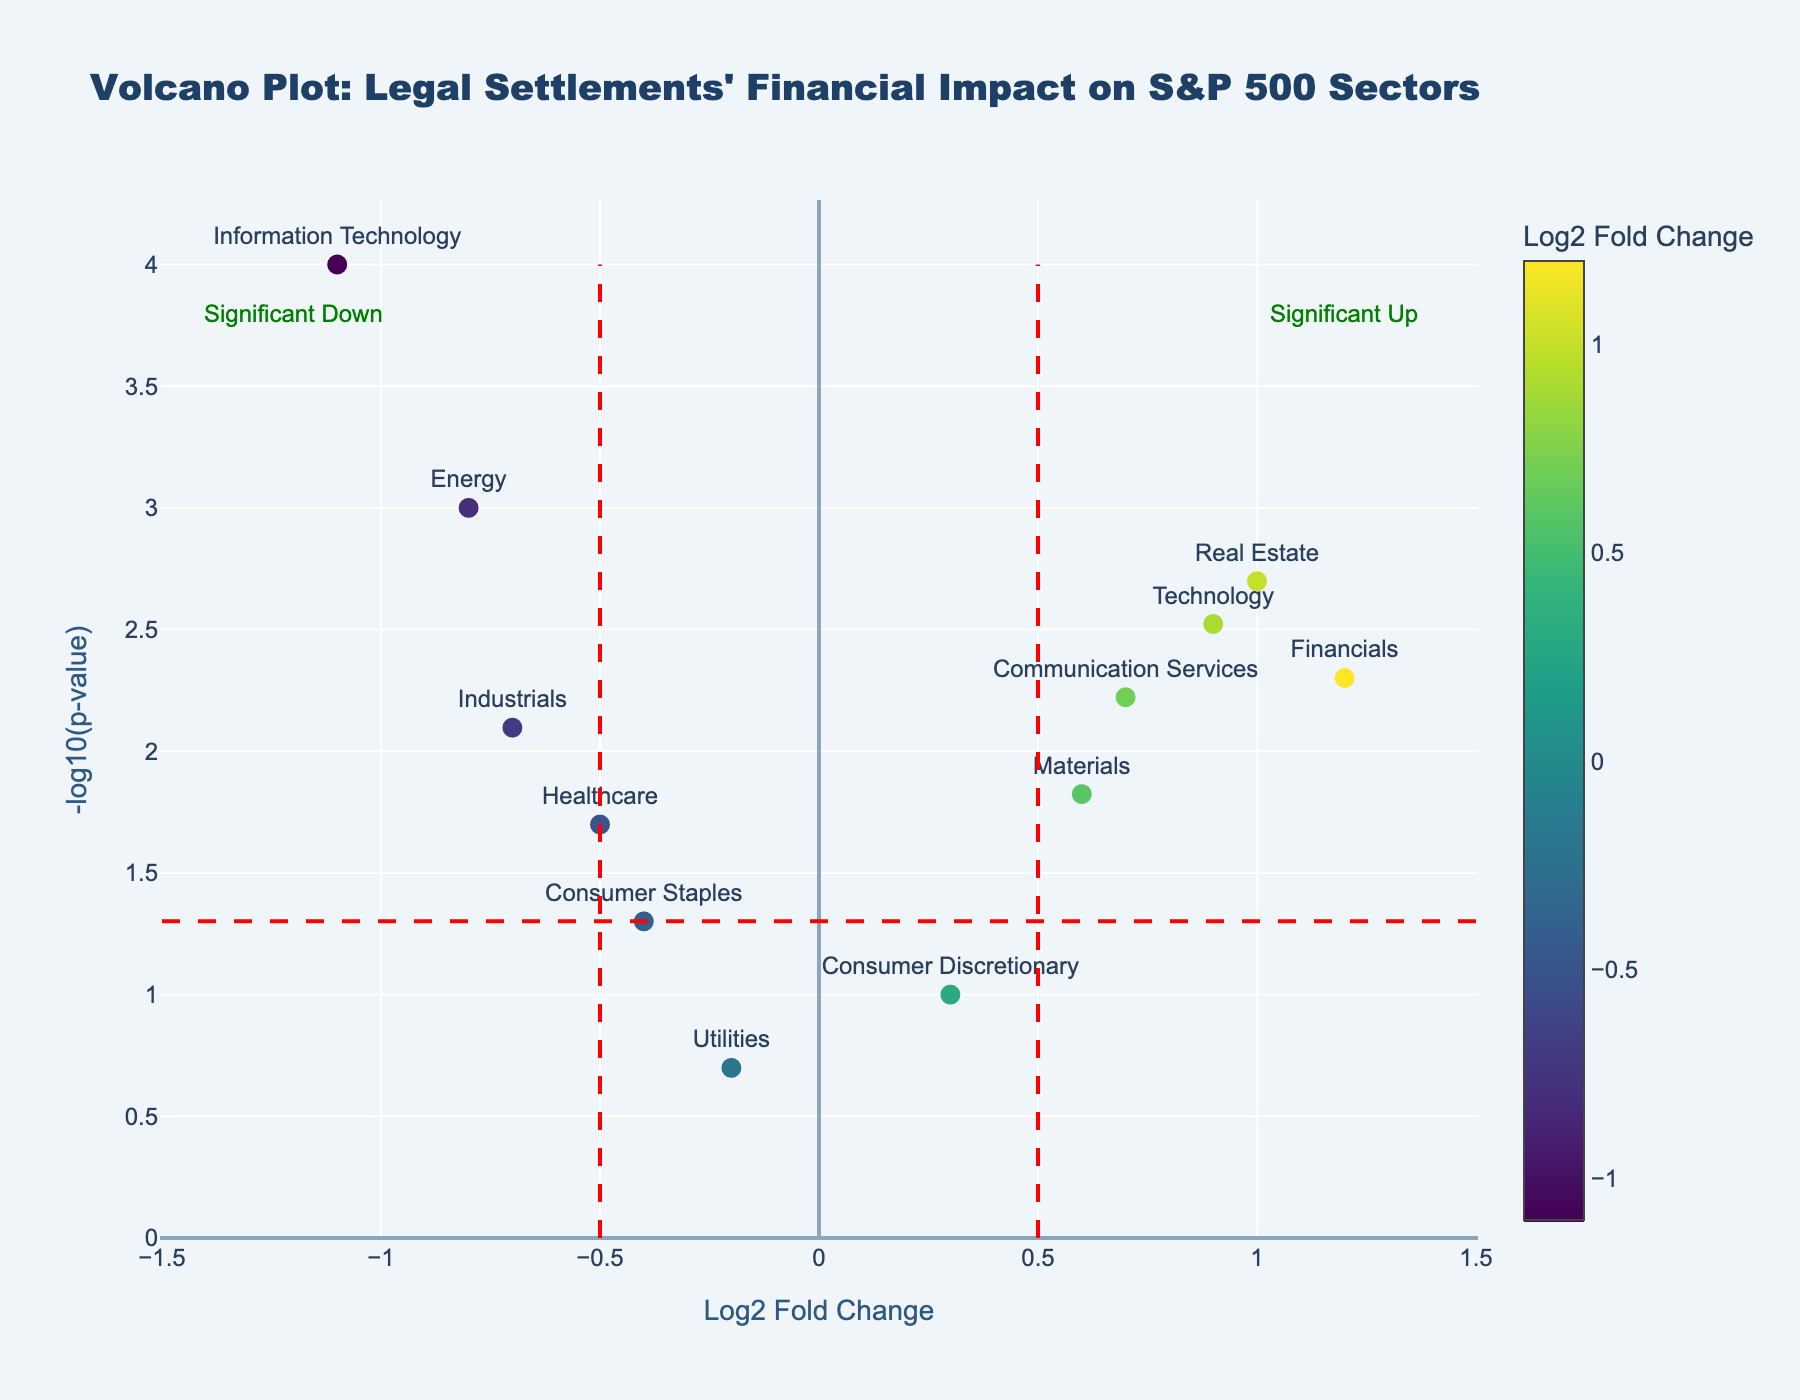What is the title of the figure? The title is at the top of the figure in large text and is easy to read. It helps contextualize what the plot is about. The title reads "Volcano Plot: Legal Settlements' Financial Impact on S&P 500 Sectors"
Answer: Volcano Plot: Legal Settlements' Financial Impact on S&P 500 Sectors How many data points are shown in the figure? Each marker represents a sector of the S&P 500, and by counting them, we find there are 12 data points.
Answer: 12 Which sector has the highest p-value? The p-value is shown on the y-axis, with lower values indicating higher points on the plot. The sector with the marker closest to the bottom of the plot is 'Utilities' with a p-value of 0.2.
Answer: Utilities Which sectors show a significant financial impact according to the fold-change threshold? Markers beyond the vertical lines at Log2 Fold Change thresholds -0.5 and 0.5 are significant. Sectors beyond these lines include 'Energy', 'Technology', 'Financials', 'Healthcare', 'Industrials', 'Materials', 'Real Estate', 'Communication Services', 'Information Technology'.
Answer: Energy, Technology, Financials, Healthcare, Industrials, Materials, Real Estate, Communication Services, Information Technology Which sector has the highest positive impact according to Log2 Fold Change? The highest positive impact is identified by the sector with the highest Log2 Fold Change value. 'Financials' has the highest Log2 Fold Change value at 1.2.
Answer: Financials Which sector has the lowest negative impact according to Log2 Fold Change? The lowest negative impact is identified by the sector with the lowest (most negative) Log2 Fold Change value. 'Information Technology' has the lowest Log2 Fold Change value at -1.1.
Answer: Information Technology What is the significance threshold for p-value in this plot? The horizontal red dashed line represents the p-value threshold. By checking the y-axis value where this line resides, it's -log10(0.05).
Answer: 0.05 Which sector falls just below the significance threshold? The sector closest below the horizontal red dashed line is 'Consumer Staples', which has a p-value of 0.05.
Answer: Consumer Staples How does the 'Healthcare' sector compare to the 'Industrial' sector in terms of Log2 Fold Change? 'Healthcare' has a Log2 Fold Change of -0.5 and 'Industrials' has -0.7, making 'Healthcare' less negatively impacted than 'Industrials'.
Answer: Healthcare is less negatively impacted than Industrials What color represents the highest positive Log2 Fold Change on the color scale? The color scale starts at a darker color and gets lighter for higher values. The lightest color (yellowish) represents the highest positive Log2 Fold Change, which corresponds to 'Financials'.
Answer: Yellow (representing Financials) 